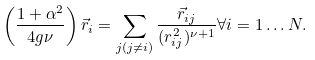Convert formula to latex. <formula><loc_0><loc_0><loc_500><loc_500>\left ( \frac { 1 + \alpha ^ { 2 } } { 4 g \nu } \right ) \vec { r } _ { i } = \sum _ { j ( j \ne i ) } \frac { \vec { r } _ { i j } } { ( r _ { i j } ^ { 2 } ) ^ { \nu + 1 } } \forall i = 1 \dots N .</formula> 